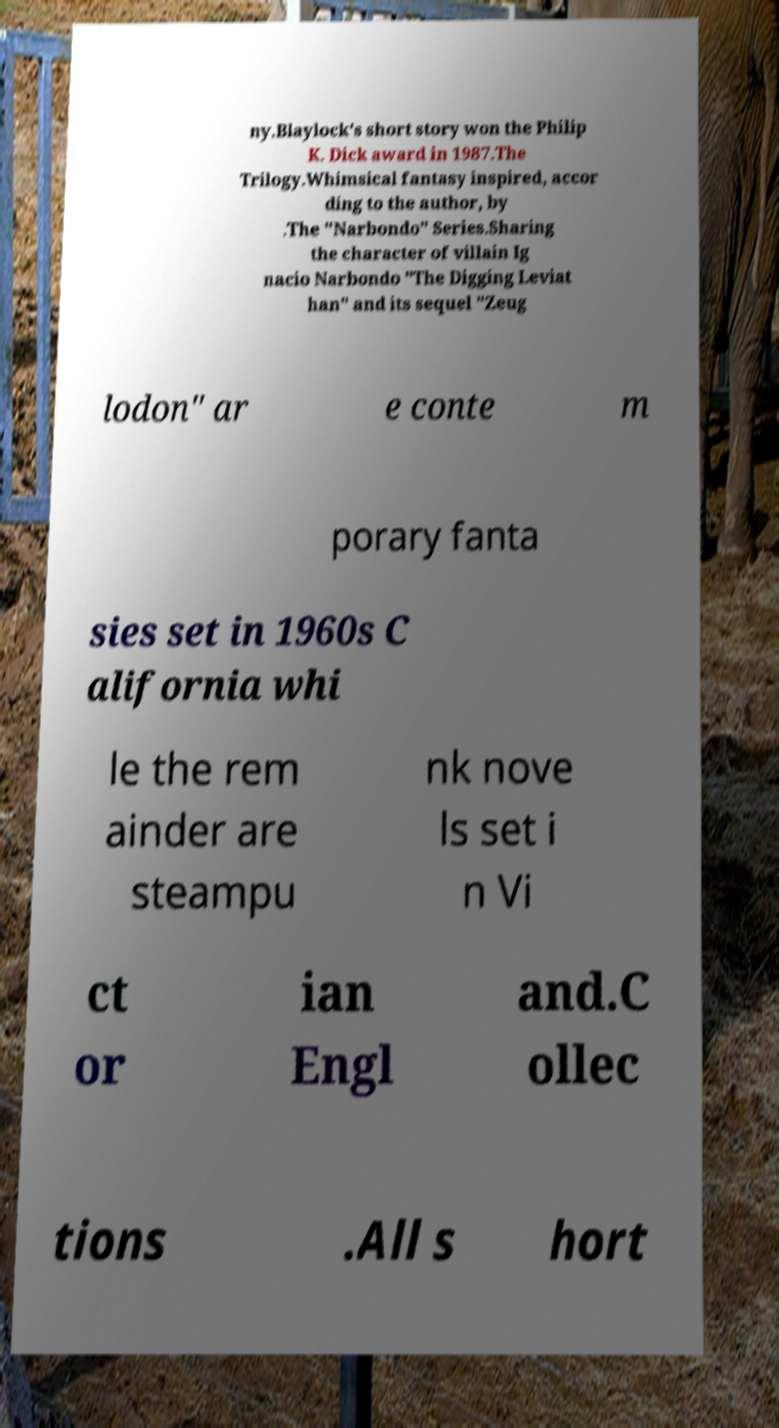For documentation purposes, I need the text within this image transcribed. Could you provide that? ny.Blaylock's short story won the Philip K. Dick award in 1987.The Trilogy.Whimsical fantasy inspired, accor ding to the author, by .The "Narbondo" Series.Sharing the character of villain Ig nacio Narbondo "The Digging Leviat han" and its sequel "Zeug lodon" ar e conte m porary fanta sies set in 1960s C alifornia whi le the rem ainder are steampu nk nove ls set i n Vi ct or ian Engl and.C ollec tions .All s hort 